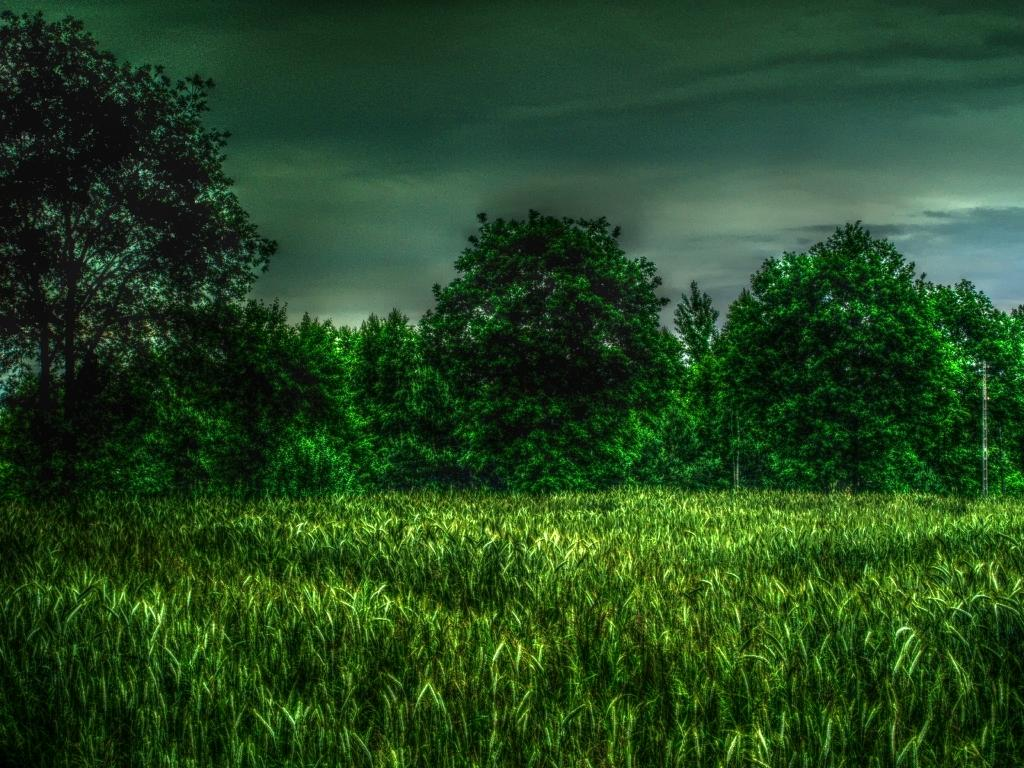What type of vegetation can be seen in the image? There are trees and plants in the image. What is visible in the background of the image? The sky is visible in the image. Can you describe the clouds in the image? Yes, there are clouds in the image. What type of stage can be seen in the image? There is no stage present in the image. How many oranges are visible in the image? There are no oranges visible in the image. 